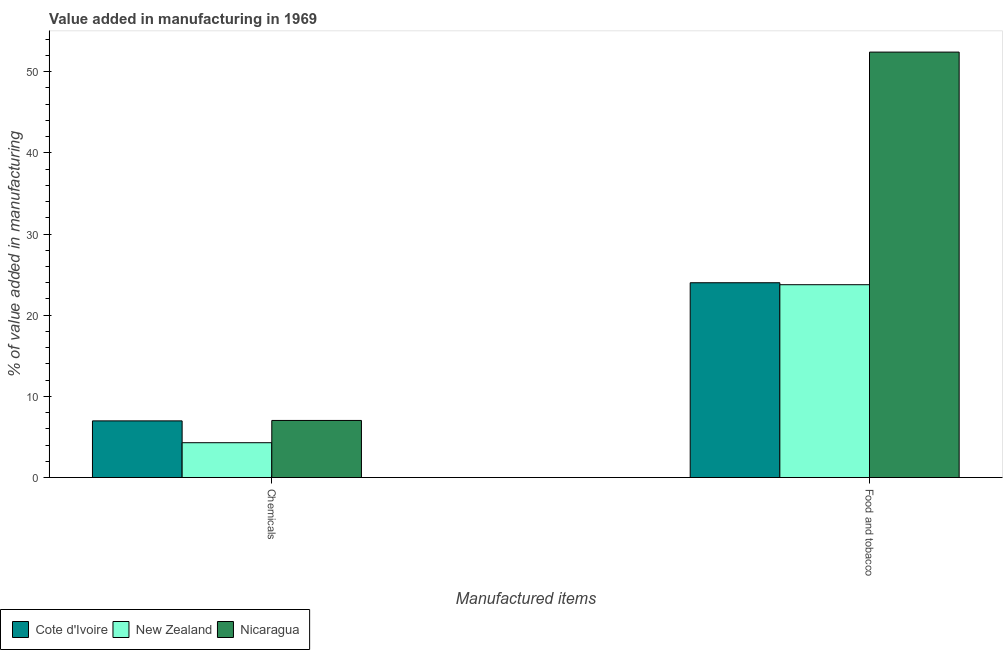How many different coloured bars are there?
Keep it short and to the point. 3. How many bars are there on the 2nd tick from the left?
Keep it short and to the point. 3. What is the label of the 2nd group of bars from the left?
Ensure brevity in your answer.  Food and tobacco. What is the value added by  manufacturing chemicals in Nicaragua?
Your answer should be compact. 7.04. Across all countries, what is the maximum value added by manufacturing food and tobacco?
Offer a terse response. 52.41. Across all countries, what is the minimum value added by  manufacturing chemicals?
Make the answer very short. 4.29. In which country was the value added by manufacturing food and tobacco maximum?
Your answer should be compact. Nicaragua. In which country was the value added by manufacturing food and tobacco minimum?
Keep it short and to the point. New Zealand. What is the total value added by manufacturing food and tobacco in the graph?
Offer a terse response. 100.17. What is the difference between the value added by  manufacturing chemicals in New Zealand and that in Nicaragua?
Your answer should be compact. -2.74. What is the difference between the value added by manufacturing food and tobacco in New Zealand and the value added by  manufacturing chemicals in Cote d'Ivoire?
Make the answer very short. 16.78. What is the average value added by  manufacturing chemicals per country?
Provide a short and direct response. 6.1. What is the difference between the value added by  manufacturing chemicals and value added by manufacturing food and tobacco in New Zealand?
Your response must be concise. -19.46. In how many countries, is the value added by manufacturing food and tobacco greater than 26 %?
Offer a terse response. 1. What is the ratio of the value added by manufacturing food and tobacco in Nicaragua to that in New Zealand?
Your answer should be compact. 2.21. What does the 1st bar from the left in Food and tobacco represents?
Your answer should be compact. Cote d'Ivoire. What does the 1st bar from the right in Chemicals represents?
Your answer should be compact. Nicaragua. What is the difference between two consecutive major ticks on the Y-axis?
Offer a very short reply. 10. Does the graph contain any zero values?
Give a very brief answer. No. Where does the legend appear in the graph?
Your response must be concise. Bottom left. How many legend labels are there?
Give a very brief answer. 3. How are the legend labels stacked?
Provide a short and direct response. Horizontal. What is the title of the graph?
Make the answer very short. Value added in manufacturing in 1969. Does "Algeria" appear as one of the legend labels in the graph?
Your answer should be compact. No. What is the label or title of the X-axis?
Ensure brevity in your answer.  Manufactured items. What is the label or title of the Y-axis?
Your answer should be compact. % of value added in manufacturing. What is the % of value added in manufacturing in Cote d'Ivoire in Chemicals?
Your answer should be very brief. 6.98. What is the % of value added in manufacturing in New Zealand in Chemicals?
Offer a very short reply. 4.29. What is the % of value added in manufacturing in Nicaragua in Chemicals?
Your response must be concise. 7.04. What is the % of value added in manufacturing in Cote d'Ivoire in Food and tobacco?
Offer a very short reply. 24. What is the % of value added in manufacturing in New Zealand in Food and tobacco?
Provide a succinct answer. 23.76. What is the % of value added in manufacturing in Nicaragua in Food and tobacco?
Ensure brevity in your answer.  52.41. Across all Manufactured items, what is the maximum % of value added in manufacturing in Cote d'Ivoire?
Give a very brief answer. 24. Across all Manufactured items, what is the maximum % of value added in manufacturing in New Zealand?
Your answer should be very brief. 23.76. Across all Manufactured items, what is the maximum % of value added in manufacturing in Nicaragua?
Your response must be concise. 52.41. Across all Manufactured items, what is the minimum % of value added in manufacturing of Cote d'Ivoire?
Give a very brief answer. 6.98. Across all Manufactured items, what is the minimum % of value added in manufacturing of New Zealand?
Your answer should be compact. 4.29. Across all Manufactured items, what is the minimum % of value added in manufacturing of Nicaragua?
Offer a terse response. 7.04. What is the total % of value added in manufacturing in Cote d'Ivoire in the graph?
Ensure brevity in your answer.  30.98. What is the total % of value added in manufacturing in New Zealand in the graph?
Provide a short and direct response. 28.05. What is the total % of value added in manufacturing of Nicaragua in the graph?
Your response must be concise. 59.45. What is the difference between the % of value added in manufacturing in Cote d'Ivoire in Chemicals and that in Food and tobacco?
Provide a short and direct response. -17.02. What is the difference between the % of value added in manufacturing of New Zealand in Chemicals and that in Food and tobacco?
Keep it short and to the point. -19.46. What is the difference between the % of value added in manufacturing of Nicaragua in Chemicals and that in Food and tobacco?
Your answer should be very brief. -45.38. What is the difference between the % of value added in manufacturing of Cote d'Ivoire in Chemicals and the % of value added in manufacturing of New Zealand in Food and tobacco?
Your answer should be compact. -16.78. What is the difference between the % of value added in manufacturing of Cote d'Ivoire in Chemicals and the % of value added in manufacturing of Nicaragua in Food and tobacco?
Your response must be concise. -45.43. What is the difference between the % of value added in manufacturing in New Zealand in Chemicals and the % of value added in manufacturing in Nicaragua in Food and tobacco?
Provide a succinct answer. -48.12. What is the average % of value added in manufacturing of Cote d'Ivoire per Manufactured items?
Offer a very short reply. 15.49. What is the average % of value added in manufacturing in New Zealand per Manufactured items?
Keep it short and to the point. 14.03. What is the average % of value added in manufacturing in Nicaragua per Manufactured items?
Provide a succinct answer. 29.73. What is the difference between the % of value added in manufacturing of Cote d'Ivoire and % of value added in manufacturing of New Zealand in Chemicals?
Make the answer very short. 2.69. What is the difference between the % of value added in manufacturing of Cote d'Ivoire and % of value added in manufacturing of Nicaragua in Chemicals?
Provide a short and direct response. -0.06. What is the difference between the % of value added in manufacturing of New Zealand and % of value added in manufacturing of Nicaragua in Chemicals?
Provide a short and direct response. -2.74. What is the difference between the % of value added in manufacturing in Cote d'Ivoire and % of value added in manufacturing in New Zealand in Food and tobacco?
Make the answer very short. 0.24. What is the difference between the % of value added in manufacturing in Cote d'Ivoire and % of value added in manufacturing in Nicaragua in Food and tobacco?
Offer a very short reply. -28.41. What is the difference between the % of value added in manufacturing of New Zealand and % of value added in manufacturing of Nicaragua in Food and tobacco?
Your answer should be very brief. -28.66. What is the ratio of the % of value added in manufacturing in Cote d'Ivoire in Chemicals to that in Food and tobacco?
Make the answer very short. 0.29. What is the ratio of the % of value added in manufacturing in New Zealand in Chemicals to that in Food and tobacco?
Your answer should be very brief. 0.18. What is the ratio of the % of value added in manufacturing in Nicaragua in Chemicals to that in Food and tobacco?
Your response must be concise. 0.13. What is the difference between the highest and the second highest % of value added in manufacturing in Cote d'Ivoire?
Ensure brevity in your answer.  17.02. What is the difference between the highest and the second highest % of value added in manufacturing in New Zealand?
Give a very brief answer. 19.46. What is the difference between the highest and the second highest % of value added in manufacturing in Nicaragua?
Provide a succinct answer. 45.38. What is the difference between the highest and the lowest % of value added in manufacturing of Cote d'Ivoire?
Your answer should be compact. 17.02. What is the difference between the highest and the lowest % of value added in manufacturing of New Zealand?
Your answer should be very brief. 19.46. What is the difference between the highest and the lowest % of value added in manufacturing of Nicaragua?
Ensure brevity in your answer.  45.38. 